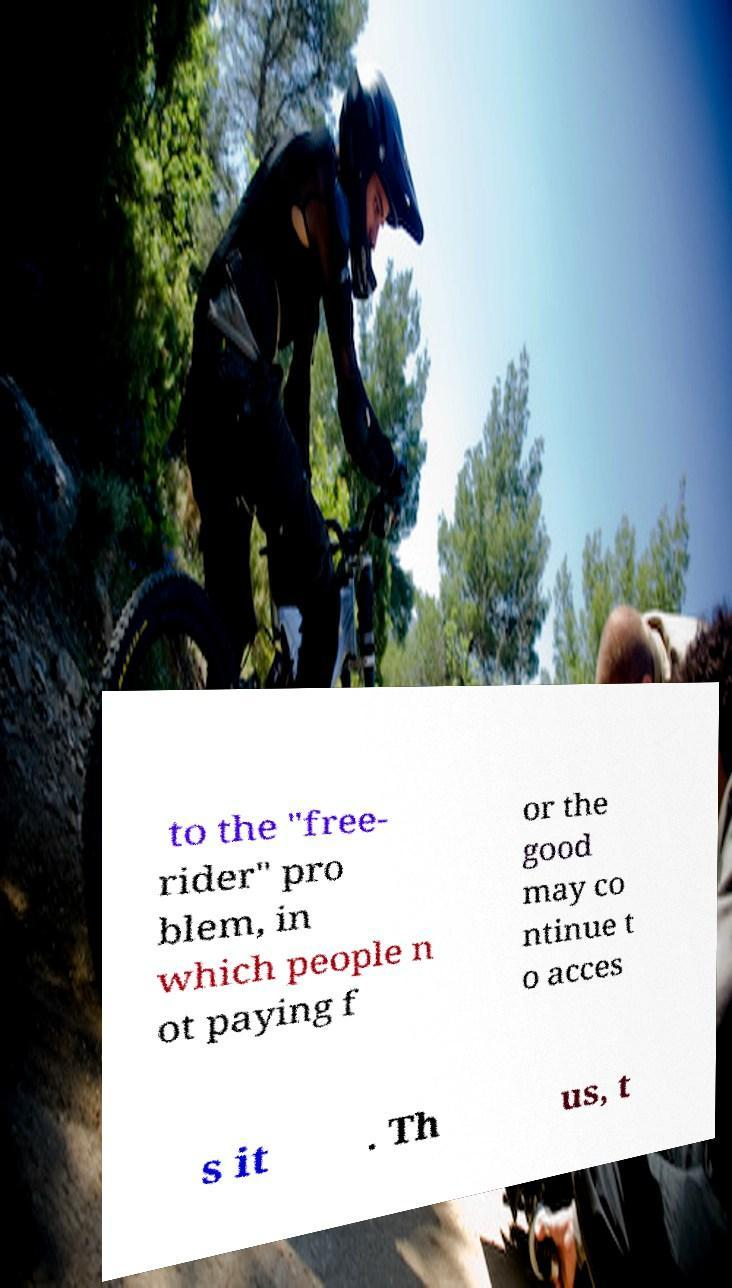Can you read and provide the text displayed in the image?This photo seems to have some interesting text. Can you extract and type it out for me? to the "free- rider" pro blem, in which people n ot paying f or the good may co ntinue t o acces s it . Th us, t 